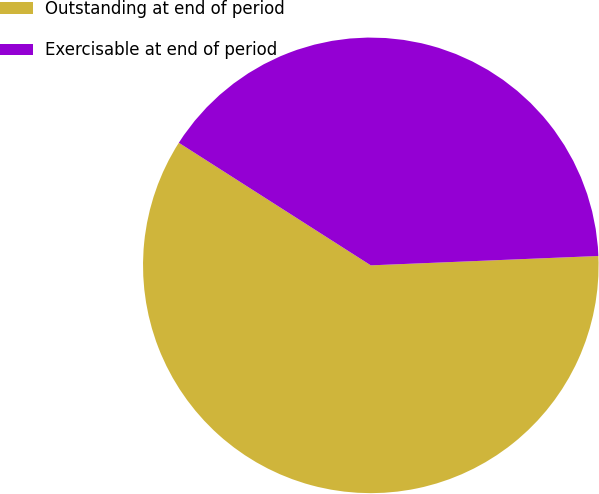Convert chart. <chart><loc_0><loc_0><loc_500><loc_500><pie_chart><fcel>Outstanding at end of period<fcel>Exercisable at end of period<nl><fcel>59.7%<fcel>40.3%<nl></chart> 